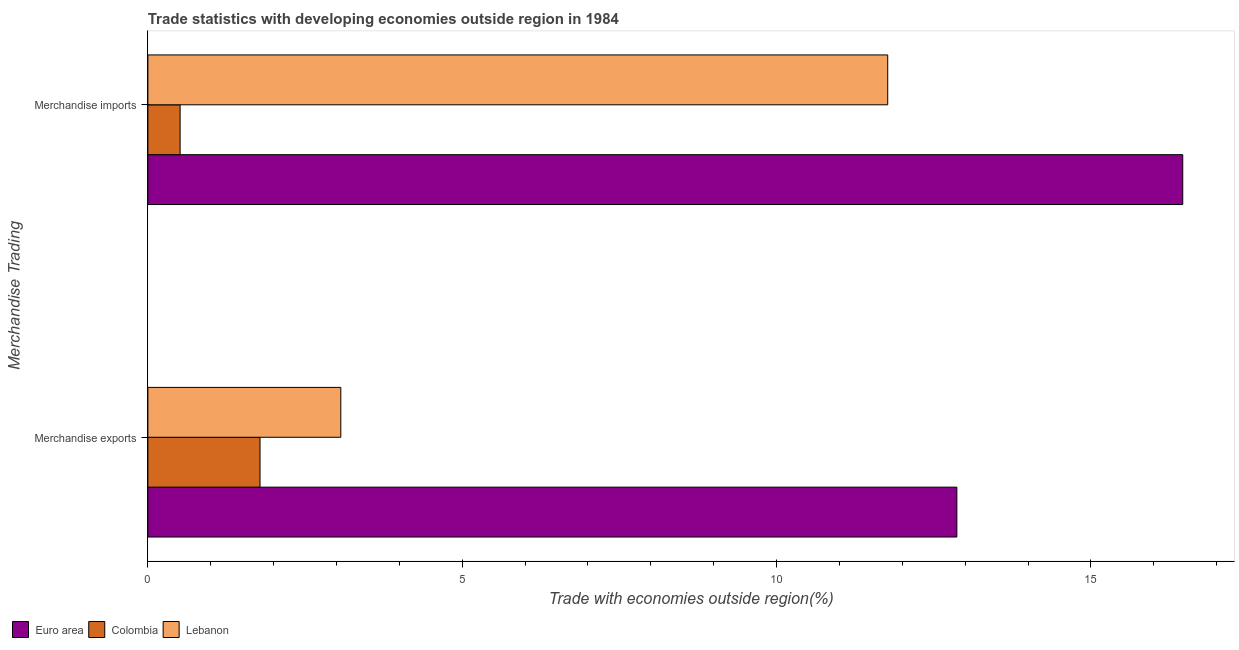How many groups of bars are there?
Make the answer very short. 2. Are the number of bars on each tick of the Y-axis equal?
Your answer should be compact. Yes. How many bars are there on the 2nd tick from the bottom?
Provide a short and direct response. 3. What is the label of the 2nd group of bars from the top?
Make the answer very short. Merchandise exports. What is the merchandise exports in Lebanon?
Your response must be concise. 3.07. Across all countries, what is the maximum merchandise exports?
Your answer should be very brief. 12.87. Across all countries, what is the minimum merchandise imports?
Your answer should be very brief. 0.51. In which country was the merchandise imports maximum?
Your answer should be compact. Euro area. In which country was the merchandise imports minimum?
Ensure brevity in your answer.  Colombia. What is the total merchandise imports in the graph?
Your answer should be very brief. 28.74. What is the difference between the merchandise exports in Colombia and that in Lebanon?
Keep it short and to the point. -1.28. What is the difference between the merchandise exports in Lebanon and the merchandise imports in Euro area?
Provide a succinct answer. -13.39. What is the average merchandise exports per country?
Keep it short and to the point. 5.91. What is the difference between the merchandise exports and merchandise imports in Lebanon?
Your answer should be compact. -8.7. What is the ratio of the merchandise exports in Lebanon to that in Euro area?
Your response must be concise. 0.24. In how many countries, is the merchandise exports greater than the average merchandise exports taken over all countries?
Offer a terse response. 1. What does the 1st bar from the top in Merchandise imports represents?
Your answer should be very brief. Lebanon. What does the 3rd bar from the bottom in Merchandise exports represents?
Your response must be concise. Lebanon. How many bars are there?
Your answer should be very brief. 6. How many countries are there in the graph?
Offer a terse response. 3. Where does the legend appear in the graph?
Give a very brief answer. Bottom left. How many legend labels are there?
Ensure brevity in your answer.  3. What is the title of the graph?
Offer a terse response. Trade statistics with developing economies outside region in 1984. What is the label or title of the X-axis?
Your answer should be compact. Trade with economies outside region(%). What is the label or title of the Y-axis?
Offer a terse response. Merchandise Trading. What is the Trade with economies outside region(%) of Euro area in Merchandise exports?
Your answer should be compact. 12.87. What is the Trade with economies outside region(%) in Colombia in Merchandise exports?
Ensure brevity in your answer.  1.78. What is the Trade with economies outside region(%) in Lebanon in Merchandise exports?
Offer a terse response. 3.07. What is the Trade with economies outside region(%) of Euro area in Merchandise imports?
Keep it short and to the point. 16.46. What is the Trade with economies outside region(%) in Colombia in Merchandise imports?
Offer a very short reply. 0.51. What is the Trade with economies outside region(%) in Lebanon in Merchandise imports?
Give a very brief answer. 11.77. Across all Merchandise Trading, what is the maximum Trade with economies outside region(%) in Euro area?
Your response must be concise. 16.46. Across all Merchandise Trading, what is the maximum Trade with economies outside region(%) of Colombia?
Ensure brevity in your answer.  1.78. Across all Merchandise Trading, what is the maximum Trade with economies outside region(%) in Lebanon?
Give a very brief answer. 11.77. Across all Merchandise Trading, what is the minimum Trade with economies outside region(%) of Euro area?
Your answer should be compact. 12.87. Across all Merchandise Trading, what is the minimum Trade with economies outside region(%) in Colombia?
Make the answer very short. 0.51. Across all Merchandise Trading, what is the minimum Trade with economies outside region(%) in Lebanon?
Provide a short and direct response. 3.07. What is the total Trade with economies outside region(%) of Euro area in the graph?
Keep it short and to the point. 29.33. What is the total Trade with economies outside region(%) in Colombia in the graph?
Offer a very short reply. 2.3. What is the total Trade with economies outside region(%) in Lebanon in the graph?
Provide a short and direct response. 14.84. What is the difference between the Trade with economies outside region(%) of Euro area in Merchandise exports and that in Merchandise imports?
Give a very brief answer. -3.59. What is the difference between the Trade with economies outside region(%) in Colombia in Merchandise exports and that in Merchandise imports?
Make the answer very short. 1.27. What is the difference between the Trade with economies outside region(%) in Lebanon in Merchandise exports and that in Merchandise imports?
Keep it short and to the point. -8.7. What is the difference between the Trade with economies outside region(%) of Euro area in Merchandise exports and the Trade with economies outside region(%) of Colombia in Merchandise imports?
Give a very brief answer. 12.35. What is the difference between the Trade with economies outside region(%) of Euro area in Merchandise exports and the Trade with economies outside region(%) of Lebanon in Merchandise imports?
Your answer should be very brief. 1.1. What is the difference between the Trade with economies outside region(%) in Colombia in Merchandise exports and the Trade with economies outside region(%) in Lebanon in Merchandise imports?
Ensure brevity in your answer.  -9.98. What is the average Trade with economies outside region(%) in Euro area per Merchandise Trading?
Give a very brief answer. 14.66. What is the average Trade with economies outside region(%) in Colombia per Merchandise Trading?
Your answer should be compact. 1.15. What is the average Trade with economies outside region(%) of Lebanon per Merchandise Trading?
Give a very brief answer. 7.42. What is the difference between the Trade with economies outside region(%) of Euro area and Trade with economies outside region(%) of Colombia in Merchandise exports?
Provide a succinct answer. 11.08. What is the difference between the Trade with economies outside region(%) of Euro area and Trade with economies outside region(%) of Lebanon in Merchandise exports?
Offer a very short reply. 9.8. What is the difference between the Trade with economies outside region(%) in Colombia and Trade with economies outside region(%) in Lebanon in Merchandise exports?
Offer a very short reply. -1.28. What is the difference between the Trade with economies outside region(%) in Euro area and Trade with economies outside region(%) in Colombia in Merchandise imports?
Provide a short and direct response. 15.95. What is the difference between the Trade with economies outside region(%) in Euro area and Trade with economies outside region(%) in Lebanon in Merchandise imports?
Provide a succinct answer. 4.69. What is the difference between the Trade with economies outside region(%) in Colombia and Trade with economies outside region(%) in Lebanon in Merchandise imports?
Your answer should be compact. -11.25. What is the ratio of the Trade with economies outside region(%) in Euro area in Merchandise exports to that in Merchandise imports?
Provide a short and direct response. 0.78. What is the ratio of the Trade with economies outside region(%) in Colombia in Merchandise exports to that in Merchandise imports?
Provide a succinct answer. 3.48. What is the ratio of the Trade with economies outside region(%) in Lebanon in Merchandise exports to that in Merchandise imports?
Make the answer very short. 0.26. What is the difference between the highest and the second highest Trade with economies outside region(%) of Euro area?
Keep it short and to the point. 3.59. What is the difference between the highest and the second highest Trade with economies outside region(%) of Colombia?
Your answer should be compact. 1.27. What is the difference between the highest and the second highest Trade with economies outside region(%) of Lebanon?
Your answer should be compact. 8.7. What is the difference between the highest and the lowest Trade with economies outside region(%) of Euro area?
Keep it short and to the point. 3.59. What is the difference between the highest and the lowest Trade with economies outside region(%) of Colombia?
Ensure brevity in your answer.  1.27. What is the difference between the highest and the lowest Trade with economies outside region(%) in Lebanon?
Keep it short and to the point. 8.7. 